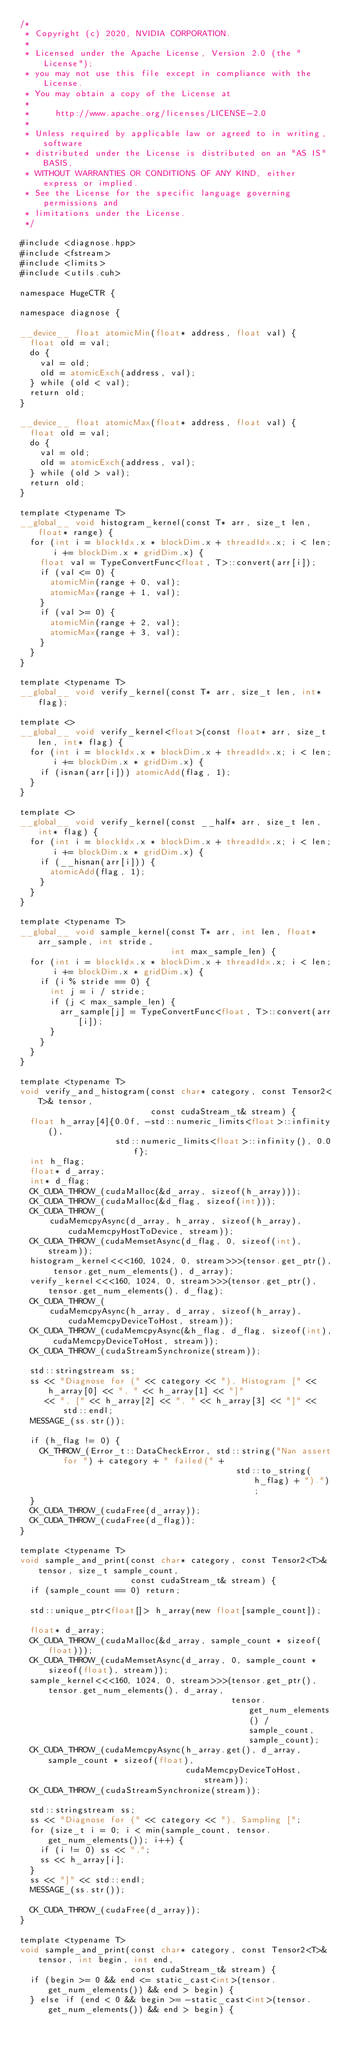Convert code to text. <code><loc_0><loc_0><loc_500><loc_500><_Cuda_>/*
 * Copyright (c) 2020, NVIDIA CORPORATION.
 *
 * Licensed under the Apache License, Version 2.0 (the "License");
 * you may not use this file except in compliance with the License.
 * You may obtain a copy of the License at
 *
 *     http://www.apache.org/licenses/LICENSE-2.0
 *
 * Unless required by applicable law or agreed to in writing, software
 * distributed under the License is distributed on an "AS IS" BASIS,
 * WITHOUT WARRANTIES OR CONDITIONS OF ANY KIND, either express or implied.
 * See the License for the specific language governing permissions and
 * limitations under the License.
 */

#include <diagnose.hpp>
#include <fstream>
#include <limits>
#include <utils.cuh>

namespace HugeCTR {

namespace diagnose {

__device__ float atomicMin(float* address, float val) {
  float old = val;
  do {
    val = old;
    old = atomicExch(address, val);
  } while (old < val);
  return old;
}

__device__ float atomicMax(float* address, float val) {
  float old = val;
  do {
    val = old;
    old = atomicExch(address, val);
  } while (old > val);
  return old;
}

template <typename T>
__global__ void histogram_kernel(const T* arr, size_t len, float* range) {
  for (int i = blockIdx.x * blockDim.x + threadIdx.x; i < len; i += blockDim.x * gridDim.x) {
    float val = TypeConvertFunc<float, T>::convert(arr[i]);
    if (val <= 0) {
      atomicMin(range + 0, val);
      atomicMax(range + 1, val);
    }
    if (val >= 0) {
      atomicMin(range + 2, val);
      atomicMax(range + 3, val);
    }
  }
}

template <typename T>
__global__ void verify_kernel(const T* arr, size_t len, int* flag);

template <>
__global__ void verify_kernel<float>(const float* arr, size_t len, int* flag) {
  for (int i = blockIdx.x * blockDim.x + threadIdx.x; i < len; i += blockDim.x * gridDim.x) {
    if (isnan(arr[i])) atomicAdd(flag, 1);
  }
}

template <>
__global__ void verify_kernel(const __half* arr, size_t len, int* flag) {
  for (int i = blockIdx.x * blockDim.x + threadIdx.x; i < len; i += blockDim.x * gridDim.x) {
    if (__hisnan(arr[i])) {
      atomicAdd(flag, 1);
    }
  }
}

template <typename T>
__global__ void sample_kernel(const T* arr, int len, float* arr_sample, int stride,
                              int max_sample_len) {
  for (int i = blockIdx.x * blockDim.x + threadIdx.x; i < len; i += blockDim.x * gridDim.x) {
    if (i % stride == 0) {
      int j = i / stride;
      if (j < max_sample_len) {
        arr_sample[j] = TypeConvertFunc<float, T>::convert(arr[i]);
      }
    }
  }
}

template <typename T>
void verify_and_histogram(const char* category, const Tensor2<T>& tensor,
                          const cudaStream_t& stream) {
  float h_array[4]{0.0f, -std::numeric_limits<float>::infinity(),
                   std::numeric_limits<float>::infinity(), 0.0f};
  int h_flag;
  float* d_array;
  int* d_flag;
  CK_CUDA_THROW_(cudaMalloc(&d_array, sizeof(h_array)));
  CK_CUDA_THROW_(cudaMalloc(&d_flag, sizeof(int)));
  CK_CUDA_THROW_(
      cudaMemcpyAsync(d_array, h_array, sizeof(h_array), cudaMemcpyHostToDevice, stream));
  CK_CUDA_THROW_(cudaMemsetAsync(d_flag, 0, sizeof(int), stream));
  histogram_kernel<<<160, 1024, 0, stream>>>(tensor.get_ptr(), tensor.get_num_elements(), d_array);
  verify_kernel<<<160, 1024, 0, stream>>>(tensor.get_ptr(), tensor.get_num_elements(), d_flag);
  CK_CUDA_THROW_(
      cudaMemcpyAsync(h_array, d_array, sizeof(h_array), cudaMemcpyDeviceToHost, stream));
  CK_CUDA_THROW_(cudaMemcpyAsync(&h_flag, d_flag, sizeof(int), cudaMemcpyDeviceToHost, stream));
  CK_CUDA_THROW_(cudaStreamSynchronize(stream));

  std::stringstream ss;
  ss << "Diagnose for (" << category << "), Histogram [" << h_array[0] << ", " << h_array[1] << "]"
     << ", [" << h_array[2] << ", " << h_array[3] << "]" << std::endl;
  MESSAGE_(ss.str());

  if (h_flag != 0) {
    CK_THROW_(Error_t::DataCheckError, std::string("Nan assert for ") + category + " failed(" +
                                           std::to_string(h_flag) + ").");
  }
  CK_CUDA_THROW_(cudaFree(d_array));
  CK_CUDA_THROW_(cudaFree(d_flag));
}

template <typename T>
void sample_and_print(const char* category, const Tensor2<T>& tensor, size_t sample_count,
                      const cudaStream_t& stream) {
  if (sample_count == 0) return;

  std::unique_ptr<float[]> h_array(new float[sample_count]);

  float* d_array;
  CK_CUDA_THROW_(cudaMalloc(&d_array, sample_count * sizeof(float)));
  CK_CUDA_THROW_(cudaMemsetAsync(d_array, 0, sample_count * sizeof(float), stream));
  sample_kernel<<<160, 1024, 0, stream>>>(tensor.get_ptr(), tensor.get_num_elements(), d_array,
                                          tensor.get_num_elements() / sample_count, sample_count);
  CK_CUDA_THROW_(cudaMemcpyAsync(h_array.get(), d_array, sample_count * sizeof(float),
                                 cudaMemcpyDeviceToHost, stream));
  CK_CUDA_THROW_(cudaStreamSynchronize(stream));

  std::stringstream ss;
  ss << "Diagnose for (" << category << "), Sampling [";
  for (size_t i = 0; i < min(sample_count, tensor.get_num_elements()); i++) {
    if (i != 0) ss << ",";
    ss << h_array[i];
  }
  ss << "]" << std::endl;
  MESSAGE_(ss.str());

  CK_CUDA_THROW_(cudaFree(d_array));
}

template <typename T>
void sample_and_print(const char* category, const Tensor2<T>& tensor, int begin, int end,
                      const cudaStream_t& stream) {
  if (begin >= 0 && end <= static_cast<int>(tensor.get_num_elements()) && end > begin) {
  } else if (end < 0 && begin >= -static_cast<int>(tensor.get_num_elements()) && end > begin) {</code> 